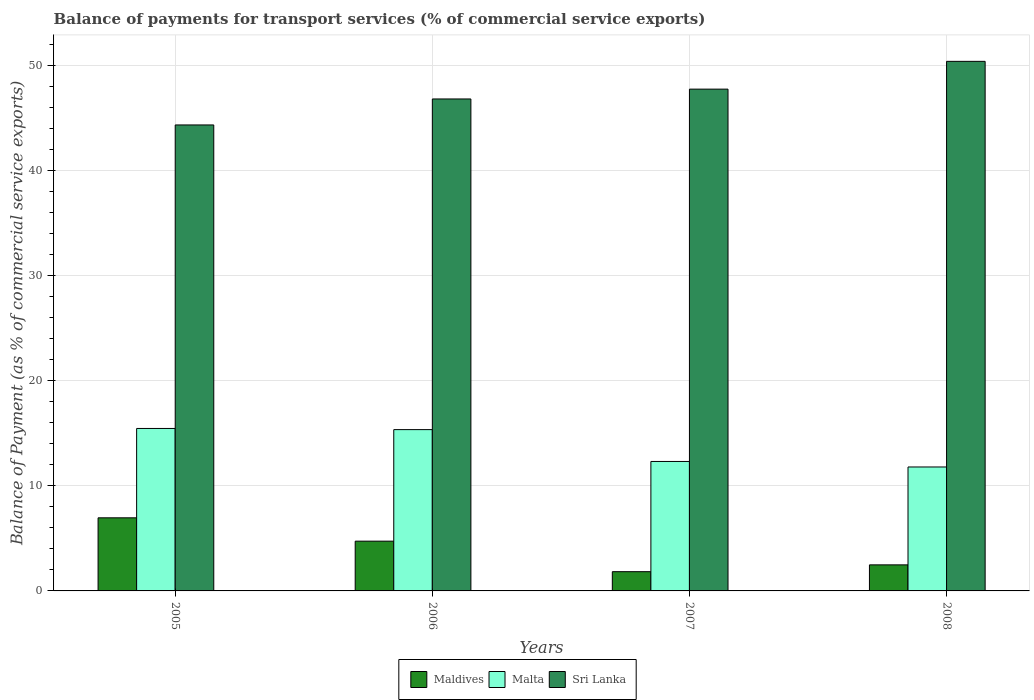How many groups of bars are there?
Provide a succinct answer. 4. Are the number of bars on each tick of the X-axis equal?
Ensure brevity in your answer.  Yes. How many bars are there on the 2nd tick from the right?
Your response must be concise. 3. What is the balance of payments for transport services in Sri Lanka in 2007?
Your answer should be compact. 47.75. Across all years, what is the maximum balance of payments for transport services in Sri Lanka?
Your answer should be very brief. 50.39. Across all years, what is the minimum balance of payments for transport services in Malta?
Your answer should be compact. 11.79. In which year was the balance of payments for transport services in Maldives maximum?
Provide a short and direct response. 2005. In which year was the balance of payments for transport services in Malta minimum?
Keep it short and to the point. 2008. What is the total balance of payments for transport services in Sri Lanka in the graph?
Ensure brevity in your answer.  189.28. What is the difference between the balance of payments for transport services in Malta in 2006 and that in 2008?
Ensure brevity in your answer.  3.55. What is the difference between the balance of payments for transport services in Maldives in 2007 and the balance of payments for transport services in Malta in 2008?
Provide a short and direct response. -9.96. What is the average balance of payments for transport services in Sri Lanka per year?
Provide a short and direct response. 47.32. In the year 2007, what is the difference between the balance of payments for transport services in Maldives and balance of payments for transport services in Sri Lanka?
Offer a terse response. -45.91. What is the ratio of the balance of payments for transport services in Maldives in 2006 to that in 2008?
Your answer should be compact. 1.91. What is the difference between the highest and the second highest balance of payments for transport services in Malta?
Offer a very short reply. 0.11. What is the difference between the highest and the lowest balance of payments for transport services in Sri Lanka?
Offer a very short reply. 6.05. What does the 1st bar from the left in 2005 represents?
Provide a succinct answer. Maldives. What does the 2nd bar from the right in 2007 represents?
Make the answer very short. Malta. Is it the case that in every year, the sum of the balance of payments for transport services in Maldives and balance of payments for transport services in Sri Lanka is greater than the balance of payments for transport services in Malta?
Give a very brief answer. Yes. What is the difference between two consecutive major ticks on the Y-axis?
Ensure brevity in your answer.  10. Where does the legend appear in the graph?
Offer a very short reply. Bottom center. What is the title of the graph?
Your answer should be compact. Balance of payments for transport services (% of commercial service exports). What is the label or title of the X-axis?
Provide a short and direct response. Years. What is the label or title of the Y-axis?
Keep it short and to the point. Balance of Payment (as % of commercial service exports). What is the Balance of Payment (as % of commercial service exports) in Maldives in 2005?
Keep it short and to the point. 6.96. What is the Balance of Payment (as % of commercial service exports) of Malta in 2005?
Your answer should be very brief. 15.46. What is the Balance of Payment (as % of commercial service exports) in Sri Lanka in 2005?
Keep it short and to the point. 44.34. What is the Balance of Payment (as % of commercial service exports) of Maldives in 2006?
Offer a very short reply. 4.73. What is the Balance of Payment (as % of commercial service exports) in Malta in 2006?
Make the answer very short. 15.35. What is the Balance of Payment (as % of commercial service exports) of Sri Lanka in 2006?
Your answer should be very brief. 46.81. What is the Balance of Payment (as % of commercial service exports) of Maldives in 2007?
Your answer should be very brief. 1.83. What is the Balance of Payment (as % of commercial service exports) in Malta in 2007?
Your response must be concise. 12.32. What is the Balance of Payment (as % of commercial service exports) of Sri Lanka in 2007?
Give a very brief answer. 47.75. What is the Balance of Payment (as % of commercial service exports) of Maldives in 2008?
Your answer should be compact. 2.48. What is the Balance of Payment (as % of commercial service exports) in Malta in 2008?
Offer a very short reply. 11.79. What is the Balance of Payment (as % of commercial service exports) of Sri Lanka in 2008?
Your answer should be very brief. 50.39. Across all years, what is the maximum Balance of Payment (as % of commercial service exports) in Maldives?
Provide a succinct answer. 6.96. Across all years, what is the maximum Balance of Payment (as % of commercial service exports) in Malta?
Provide a short and direct response. 15.46. Across all years, what is the maximum Balance of Payment (as % of commercial service exports) of Sri Lanka?
Offer a very short reply. 50.39. Across all years, what is the minimum Balance of Payment (as % of commercial service exports) of Maldives?
Your response must be concise. 1.83. Across all years, what is the minimum Balance of Payment (as % of commercial service exports) of Malta?
Keep it short and to the point. 11.79. Across all years, what is the minimum Balance of Payment (as % of commercial service exports) in Sri Lanka?
Give a very brief answer. 44.34. What is the total Balance of Payment (as % of commercial service exports) of Maldives in the graph?
Give a very brief answer. 16. What is the total Balance of Payment (as % of commercial service exports) in Malta in the graph?
Your answer should be compact. 54.92. What is the total Balance of Payment (as % of commercial service exports) in Sri Lanka in the graph?
Make the answer very short. 189.28. What is the difference between the Balance of Payment (as % of commercial service exports) in Maldives in 2005 and that in 2006?
Ensure brevity in your answer.  2.22. What is the difference between the Balance of Payment (as % of commercial service exports) of Malta in 2005 and that in 2006?
Offer a terse response. 0.11. What is the difference between the Balance of Payment (as % of commercial service exports) of Sri Lanka in 2005 and that in 2006?
Give a very brief answer. -2.47. What is the difference between the Balance of Payment (as % of commercial service exports) of Maldives in 2005 and that in 2007?
Make the answer very short. 5.12. What is the difference between the Balance of Payment (as % of commercial service exports) in Malta in 2005 and that in 2007?
Your answer should be compact. 3.14. What is the difference between the Balance of Payment (as % of commercial service exports) in Sri Lanka in 2005 and that in 2007?
Offer a very short reply. -3.41. What is the difference between the Balance of Payment (as % of commercial service exports) of Maldives in 2005 and that in 2008?
Make the answer very short. 4.48. What is the difference between the Balance of Payment (as % of commercial service exports) of Malta in 2005 and that in 2008?
Your response must be concise. 3.67. What is the difference between the Balance of Payment (as % of commercial service exports) of Sri Lanka in 2005 and that in 2008?
Provide a short and direct response. -6.05. What is the difference between the Balance of Payment (as % of commercial service exports) in Maldives in 2006 and that in 2007?
Your answer should be compact. 2.9. What is the difference between the Balance of Payment (as % of commercial service exports) in Malta in 2006 and that in 2007?
Ensure brevity in your answer.  3.03. What is the difference between the Balance of Payment (as % of commercial service exports) in Sri Lanka in 2006 and that in 2007?
Give a very brief answer. -0.94. What is the difference between the Balance of Payment (as % of commercial service exports) in Maldives in 2006 and that in 2008?
Give a very brief answer. 2.25. What is the difference between the Balance of Payment (as % of commercial service exports) of Malta in 2006 and that in 2008?
Ensure brevity in your answer.  3.55. What is the difference between the Balance of Payment (as % of commercial service exports) in Sri Lanka in 2006 and that in 2008?
Your answer should be very brief. -3.58. What is the difference between the Balance of Payment (as % of commercial service exports) of Maldives in 2007 and that in 2008?
Make the answer very short. -0.65. What is the difference between the Balance of Payment (as % of commercial service exports) in Malta in 2007 and that in 2008?
Provide a short and direct response. 0.52. What is the difference between the Balance of Payment (as % of commercial service exports) in Sri Lanka in 2007 and that in 2008?
Offer a very short reply. -2.64. What is the difference between the Balance of Payment (as % of commercial service exports) of Maldives in 2005 and the Balance of Payment (as % of commercial service exports) of Malta in 2006?
Your answer should be compact. -8.39. What is the difference between the Balance of Payment (as % of commercial service exports) in Maldives in 2005 and the Balance of Payment (as % of commercial service exports) in Sri Lanka in 2006?
Keep it short and to the point. -39.85. What is the difference between the Balance of Payment (as % of commercial service exports) in Malta in 2005 and the Balance of Payment (as % of commercial service exports) in Sri Lanka in 2006?
Your response must be concise. -31.35. What is the difference between the Balance of Payment (as % of commercial service exports) of Maldives in 2005 and the Balance of Payment (as % of commercial service exports) of Malta in 2007?
Keep it short and to the point. -5.36. What is the difference between the Balance of Payment (as % of commercial service exports) of Maldives in 2005 and the Balance of Payment (as % of commercial service exports) of Sri Lanka in 2007?
Provide a short and direct response. -40.79. What is the difference between the Balance of Payment (as % of commercial service exports) in Malta in 2005 and the Balance of Payment (as % of commercial service exports) in Sri Lanka in 2007?
Keep it short and to the point. -32.29. What is the difference between the Balance of Payment (as % of commercial service exports) in Maldives in 2005 and the Balance of Payment (as % of commercial service exports) in Malta in 2008?
Make the answer very short. -4.84. What is the difference between the Balance of Payment (as % of commercial service exports) in Maldives in 2005 and the Balance of Payment (as % of commercial service exports) in Sri Lanka in 2008?
Give a very brief answer. -43.43. What is the difference between the Balance of Payment (as % of commercial service exports) in Malta in 2005 and the Balance of Payment (as % of commercial service exports) in Sri Lanka in 2008?
Offer a very short reply. -34.93. What is the difference between the Balance of Payment (as % of commercial service exports) in Maldives in 2006 and the Balance of Payment (as % of commercial service exports) in Malta in 2007?
Provide a short and direct response. -7.58. What is the difference between the Balance of Payment (as % of commercial service exports) of Maldives in 2006 and the Balance of Payment (as % of commercial service exports) of Sri Lanka in 2007?
Offer a terse response. -43.01. What is the difference between the Balance of Payment (as % of commercial service exports) in Malta in 2006 and the Balance of Payment (as % of commercial service exports) in Sri Lanka in 2007?
Provide a short and direct response. -32.4. What is the difference between the Balance of Payment (as % of commercial service exports) in Maldives in 2006 and the Balance of Payment (as % of commercial service exports) in Malta in 2008?
Ensure brevity in your answer.  -7.06. What is the difference between the Balance of Payment (as % of commercial service exports) of Maldives in 2006 and the Balance of Payment (as % of commercial service exports) of Sri Lanka in 2008?
Offer a very short reply. -45.65. What is the difference between the Balance of Payment (as % of commercial service exports) of Malta in 2006 and the Balance of Payment (as % of commercial service exports) of Sri Lanka in 2008?
Keep it short and to the point. -35.04. What is the difference between the Balance of Payment (as % of commercial service exports) of Maldives in 2007 and the Balance of Payment (as % of commercial service exports) of Malta in 2008?
Offer a terse response. -9.96. What is the difference between the Balance of Payment (as % of commercial service exports) in Maldives in 2007 and the Balance of Payment (as % of commercial service exports) in Sri Lanka in 2008?
Make the answer very short. -48.56. What is the difference between the Balance of Payment (as % of commercial service exports) of Malta in 2007 and the Balance of Payment (as % of commercial service exports) of Sri Lanka in 2008?
Ensure brevity in your answer.  -38.07. What is the average Balance of Payment (as % of commercial service exports) of Maldives per year?
Keep it short and to the point. 4. What is the average Balance of Payment (as % of commercial service exports) of Malta per year?
Your answer should be very brief. 13.73. What is the average Balance of Payment (as % of commercial service exports) in Sri Lanka per year?
Offer a terse response. 47.32. In the year 2005, what is the difference between the Balance of Payment (as % of commercial service exports) in Maldives and Balance of Payment (as % of commercial service exports) in Malta?
Offer a very short reply. -8.5. In the year 2005, what is the difference between the Balance of Payment (as % of commercial service exports) in Maldives and Balance of Payment (as % of commercial service exports) in Sri Lanka?
Offer a very short reply. -37.38. In the year 2005, what is the difference between the Balance of Payment (as % of commercial service exports) of Malta and Balance of Payment (as % of commercial service exports) of Sri Lanka?
Your response must be concise. -28.88. In the year 2006, what is the difference between the Balance of Payment (as % of commercial service exports) in Maldives and Balance of Payment (as % of commercial service exports) in Malta?
Make the answer very short. -10.61. In the year 2006, what is the difference between the Balance of Payment (as % of commercial service exports) in Maldives and Balance of Payment (as % of commercial service exports) in Sri Lanka?
Provide a short and direct response. -42.08. In the year 2006, what is the difference between the Balance of Payment (as % of commercial service exports) of Malta and Balance of Payment (as % of commercial service exports) of Sri Lanka?
Provide a short and direct response. -31.46. In the year 2007, what is the difference between the Balance of Payment (as % of commercial service exports) of Maldives and Balance of Payment (as % of commercial service exports) of Malta?
Your answer should be compact. -10.49. In the year 2007, what is the difference between the Balance of Payment (as % of commercial service exports) in Maldives and Balance of Payment (as % of commercial service exports) in Sri Lanka?
Ensure brevity in your answer.  -45.91. In the year 2007, what is the difference between the Balance of Payment (as % of commercial service exports) of Malta and Balance of Payment (as % of commercial service exports) of Sri Lanka?
Provide a short and direct response. -35.43. In the year 2008, what is the difference between the Balance of Payment (as % of commercial service exports) of Maldives and Balance of Payment (as % of commercial service exports) of Malta?
Ensure brevity in your answer.  -9.31. In the year 2008, what is the difference between the Balance of Payment (as % of commercial service exports) in Maldives and Balance of Payment (as % of commercial service exports) in Sri Lanka?
Provide a short and direct response. -47.91. In the year 2008, what is the difference between the Balance of Payment (as % of commercial service exports) in Malta and Balance of Payment (as % of commercial service exports) in Sri Lanka?
Offer a terse response. -38.6. What is the ratio of the Balance of Payment (as % of commercial service exports) in Maldives in 2005 to that in 2006?
Ensure brevity in your answer.  1.47. What is the ratio of the Balance of Payment (as % of commercial service exports) in Sri Lanka in 2005 to that in 2006?
Give a very brief answer. 0.95. What is the ratio of the Balance of Payment (as % of commercial service exports) in Maldives in 2005 to that in 2007?
Offer a very short reply. 3.8. What is the ratio of the Balance of Payment (as % of commercial service exports) in Malta in 2005 to that in 2007?
Provide a short and direct response. 1.25. What is the ratio of the Balance of Payment (as % of commercial service exports) of Sri Lanka in 2005 to that in 2007?
Keep it short and to the point. 0.93. What is the ratio of the Balance of Payment (as % of commercial service exports) in Maldives in 2005 to that in 2008?
Offer a terse response. 2.81. What is the ratio of the Balance of Payment (as % of commercial service exports) in Malta in 2005 to that in 2008?
Your response must be concise. 1.31. What is the ratio of the Balance of Payment (as % of commercial service exports) in Sri Lanka in 2005 to that in 2008?
Offer a very short reply. 0.88. What is the ratio of the Balance of Payment (as % of commercial service exports) of Maldives in 2006 to that in 2007?
Provide a succinct answer. 2.58. What is the ratio of the Balance of Payment (as % of commercial service exports) of Malta in 2006 to that in 2007?
Give a very brief answer. 1.25. What is the ratio of the Balance of Payment (as % of commercial service exports) of Sri Lanka in 2006 to that in 2007?
Make the answer very short. 0.98. What is the ratio of the Balance of Payment (as % of commercial service exports) in Maldives in 2006 to that in 2008?
Offer a terse response. 1.91. What is the ratio of the Balance of Payment (as % of commercial service exports) in Malta in 2006 to that in 2008?
Give a very brief answer. 1.3. What is the ratio of the Balance of Payment (as % of commercial service exports) in Sri Lanka in 2006 to that in 2008?
Your response must be concise. 0.93. What is the ratio of the Balance of Payment (as % of commercial service exports) in Maldives in 2007 to that in 2008?
Your answer should be compact. 0.74. What is the ratio of the Balance of Payment (as % of commercial service exports) in Malta in 2007 to that in 2008?
Provide a succinct answer. 1.04. What is the ratio of the Balance of Payment (as % of commercial service exports) of Sri Lanka in 2007 to that in 2008?
Give a very brief answer. 0.95. What is the difference between the highest and the second highest Balance of Payment (as % of commercial service exports) in Maldives?
Ensure brevity in your answer.  2.22. What is the difference between the highest and the second highest Balance of Payment (as % of commercial service exports) of Malta?
Provide a short and direct response. 0.11. What is the difference between the highest and the second highest Balance of Payment (as % of commercial service exports) in Sri Lanka?
Give a very brief answer. 2.64. What is the difference between the highest and the lowest Balance of Payment (as % of commercial service exports) in Maldives?
Offer a very short reply. 5.12. What is the difference between the highest and the lowest Balance of Payment (as % of commercial service exports) of Malta?
Provide a short and direct response. 3.67. What is the difference between the highest and the lowest Balance of Payment (as % of commercial service exports) of Sri Lanka?
Make the answer very short. 6.05. 